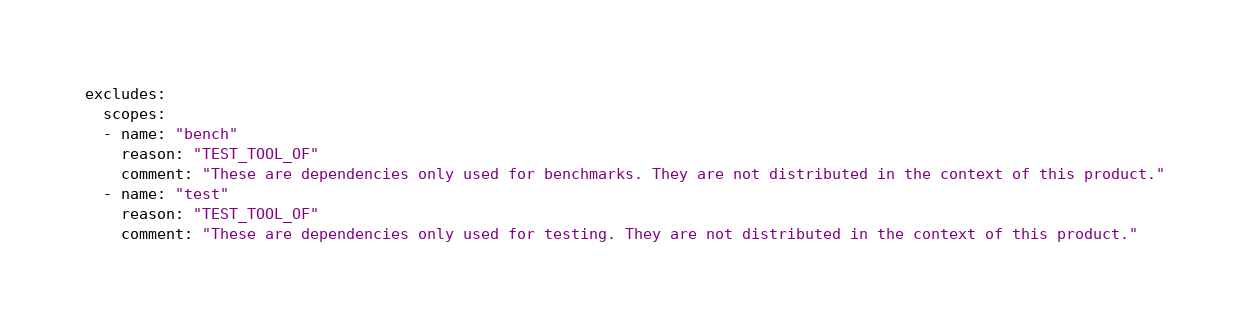Convert code to text. <code><loc_0><loc_0><loc_500><loc_500><_YAML_>excludes:
  scopes:
  - name: "bench"
    reason: "TEST_TOOL_OF"
    comment: "These are dependencies only used for benchmarks. They are not distributed in the context of this product."
  - name: "test"
    reason: "TEST_TOOL_OF"
    comment: "These are dependencies only used for testing. They are not distributed in the context of this product."
</code> 